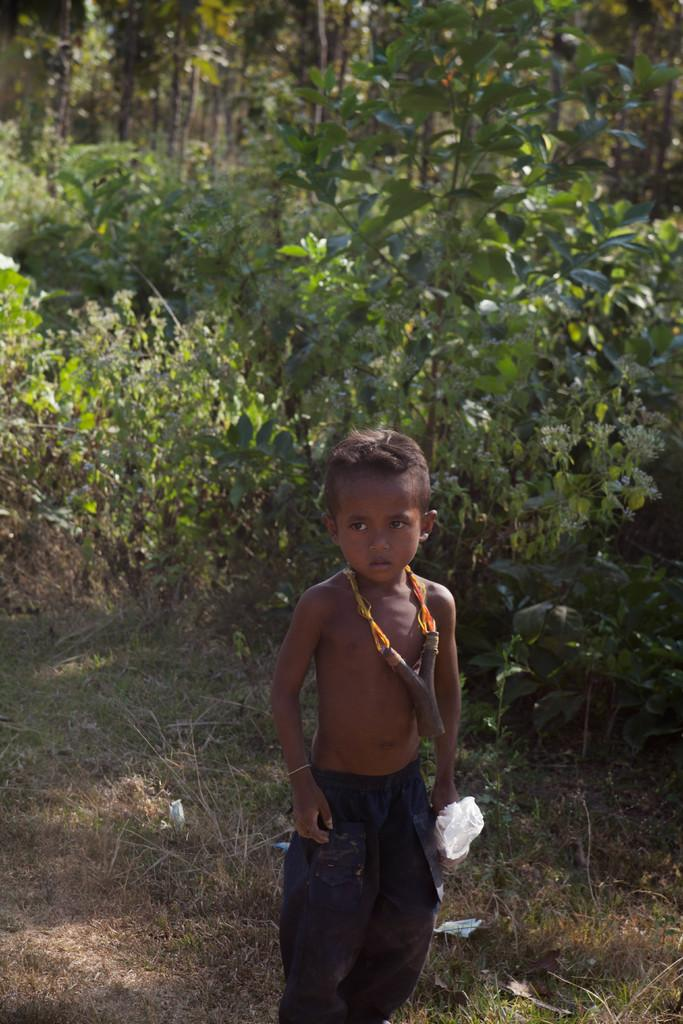Who is the main subject in the image? There is a boy in the image. What can be seen in the background of the image? Trees are visible in the background of the image. What is the boy holding in his hand? The boy is holding a carry bag in his hand. What type of vegetation is present on the ground in the image? Grass is present on the ground in the image. What type of pencil can be seen in the boy's hand in the image? There is no pencil present in the boy's hand or in the image. 